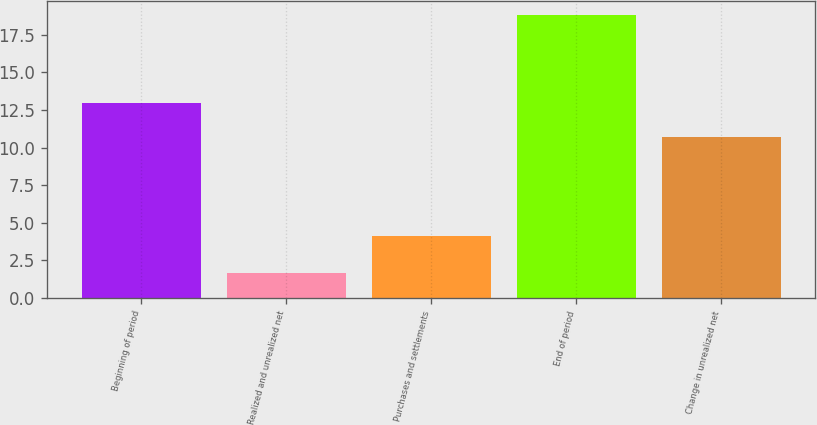Convert chart. <chart><loc_0><loc_0><loc_500><loc_500><bar_chart><fcel>Beginning of period<fcel>Realized and unrealized net<fcel>Purchases and settlements<fcel>End of period<fcel>Change in unrealized net<nl><fcel>13<fcel>1.7<fcel>4.1<fcel>18.8<fcel>10.7<nl></chart> 